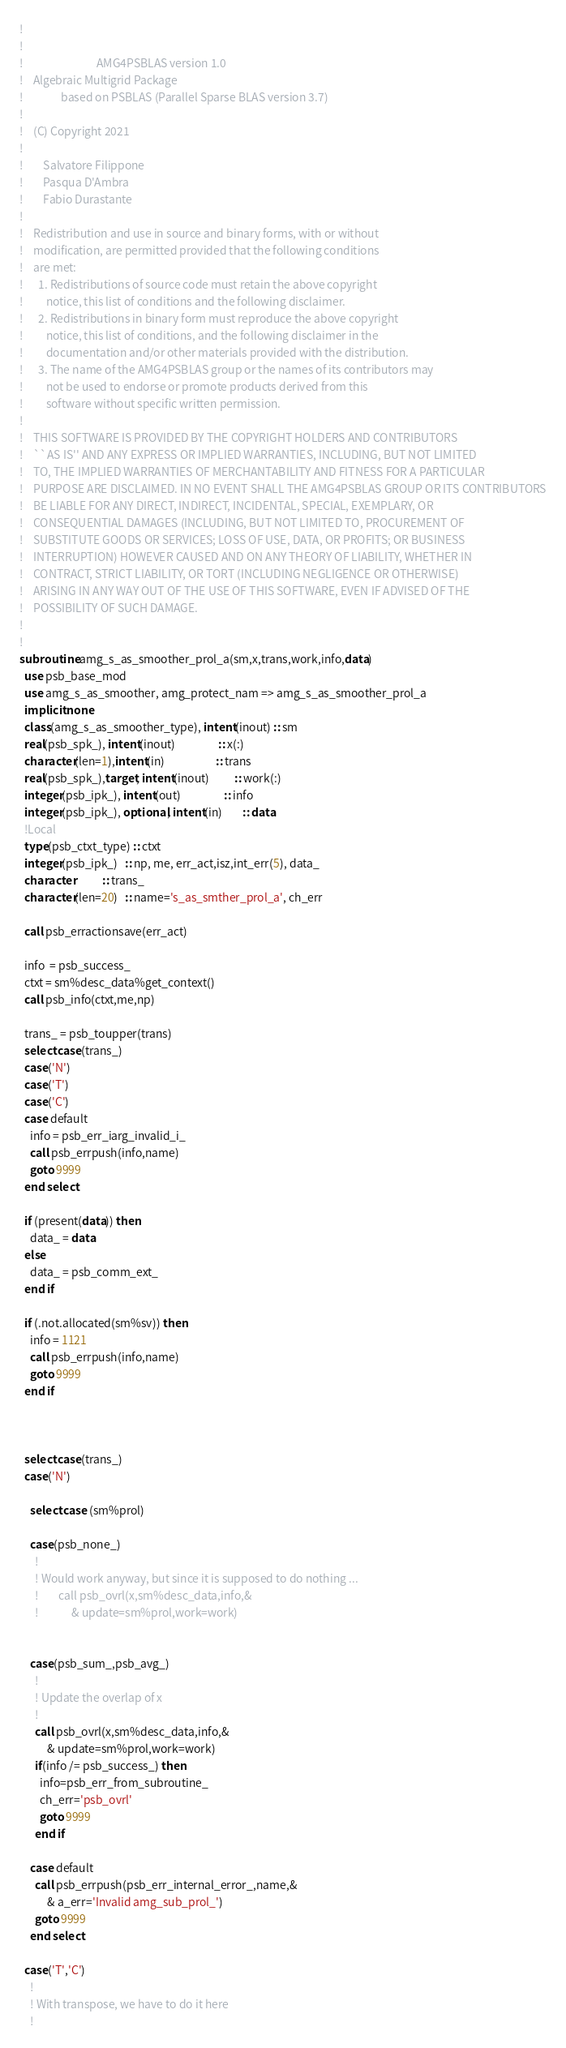<code> <loc_0><loc_0><loc_500><loc_500><_FORTRAN_>!  
!   
!                             AMG4PSBLAS version 1.0
!    Algebraic Multigrid Package
!               based on PSBLAS (Parallel Sparse BLAS version 3.7)
!    
!    (C) Copyright 2021 
!  
!        Salvatore Filippone  
!        Pasqua D'Ambra   
!        Fabio Durastante        
!   
!    Redistribution and use in source and binary forms, with or without
!    modification, are permitted provided that the following conditions
!    are met:
!      1. Redistributions of source code must retain the above copyright
!         notice, this list of conditions and the following disclaimer.
!      2. Redistributions in binary form must reproduce the above copyright
!         notice, this list of conditions, and the following disclaimer in the
!         documentation and/or other materials provided with the distribution.
!      3. The name of the AMG4PSBLAS group or the names of its contributors may
!         not be used to endorse or promote products derived from this
!         software without specific written permission.
!   
!    THIS SOFTWARE IS PROVIDED BY THE COPYRIGHT HOLDERS AND CONTRIBUTORS
!    ``AS IS'' AND ANY EXPRESS OR IMPLIED WARRANTIES, INCLUDING, BUT NOT LIMITED
!    TO, THE IMPLIED WARRANTIES OF MERCHANTABILITY AND FITNESS FOR A PARTICULAR
!    PURPOSE ARE DISCLAIMED. IN NO EVENT SHALL THE AMG4PSBLAS GROUP OR ITS CONTRIBUTORS
!    BE LIABLE FOR ANY DIRECT, INDIRECT, INCIDENTAL, SPECIAL, EXEMPLARY, OR
!    CONSEQUENTIAL DAMAGES (INCLUDING, BUT NOT LIMITED TO, PROCUREMENT OF
!    SUBSTITUTE GOODS OR SERVICES; LOSS OF USE, DATA, OR PROFITS; OR BUSINESS
!    INTERRUPTION) HOWEVER CAUSED AND ON ANY THEORY OF LIABILITY, WHETHER IN
!    CONTRACT, STRICT LIABILITY, OR TORT (INCLUDING NEGLIGENCE OR OTHERWISE)
!    ARISING IN ANY WAY OUT OF THE USE OF THIS SOFTWARE, EVEN IF ADVISED OF THE
!    POSSIBILITY OF SUCH DAMAGE.
!   
!  
subroutine amg_s_as_smoother_prol_a(sm,x,trans,work,info,data)
  use psb_base_mod
  use amg_s_as_smoother, amg_protect_nam => amg_s_as_smoother_prol_a
  implicit none 
  class(amg_s_as_smoother_type), intent(inout) :: sm
  real(psb_spk_), intent(inout)                 :: x(:)
  character(len=1),intent(in)                    :: trans
  real(psb_spk_),target, intent(inout)          :: work(:)
  integer(psb_ipk_), intent(out)                 :: info
  integer(psb_ipk_), optional, intent(in)        :: data
  !Local
  type(psb_ctxt_type) :: ctxt
  integer(psb_ipk_)   :: np, me, err_act,isz,int_err(5), data_
  character           :: trans_
  character(len=20)   :: name='s_as_smther_prol_a', ch_err

  call psb_erractionsave(err_act)

  info  = psb_success_
  ctxt = sm%desc_data%get_context()
  call psb_info(ctxt,me,np)

  trans_ = psb_toupper(trans)
  select case(trans_)
  case('N')
  case('T')
  case('C')
  case default
    info = psb_err_iarg_invalid_i_
    call psb_errpush(info,name)
    goto 9999
  end select

  if (present(data)) then
    data_ = data
  else
    data_ = psb_comm_ext_
  end if

  if (.not.allocated(sm%sv)) then 
    info = 1121
    call psb_errpush(info,name)
    goto 9999
  end if



  select case(trans_)
  case('N')

    select case (sm%prol) 

    case(psb_none_)
      ! 
      ! Would work anyway, but since it is supposed to do nothing ...
      !        call psb_ovrl(x,sm%desc_data,info,&
      !             & update=sm%prol,work=work)


    case(psb_sum_,psb_avg_) 
      !
      ! Update the overlap of x
      !
      call psb_ovrl(x,sm%desc_data,info,&
           & update=sm%prol,work=work)
      if(info /= psb_success_) then
        info=psb_err_from_subroutine_
        ch_err='psb_ovrl'
        goto 9999
      end if

    case default
      call psb_errpush(psb_err_internal_error_,name,&
           & a_err='Invalid amg_sub_prol_')
      goto 9999
    end select

  case('T','C')
    !
    ! With transpose, we have to do it here
    ! </code> 